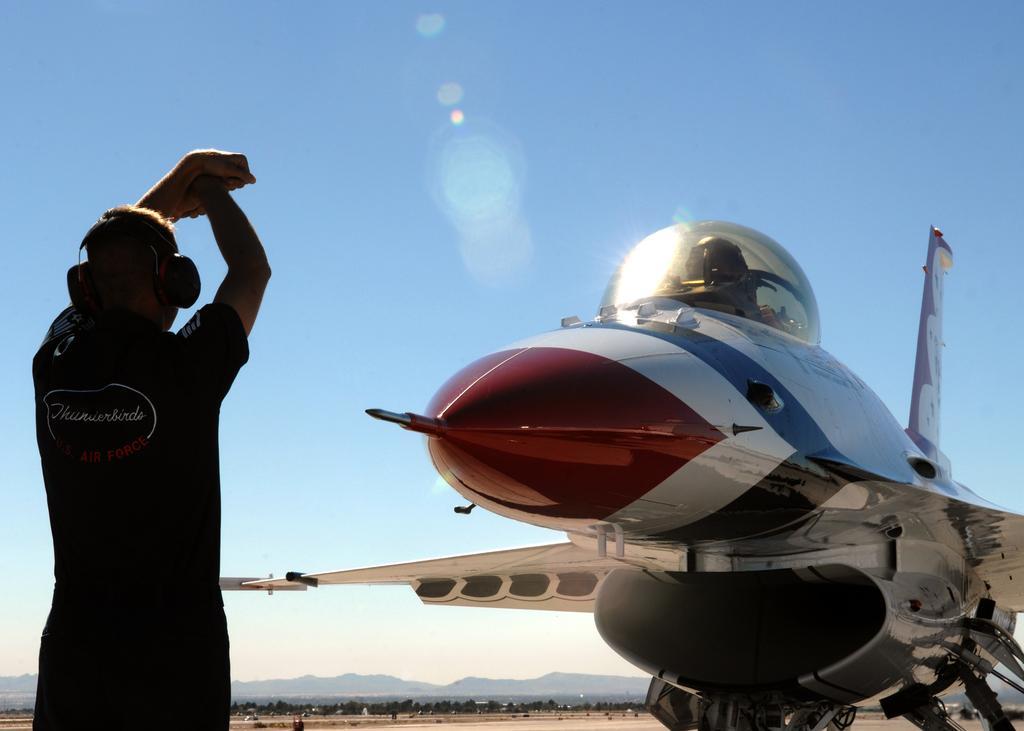Can you describe this image briefly? In this picture I can see a person in front who is standing and I see that he is wearing a headphone on his head. In the center of this picture I can see an aircraft. In the background I can see the sky. 